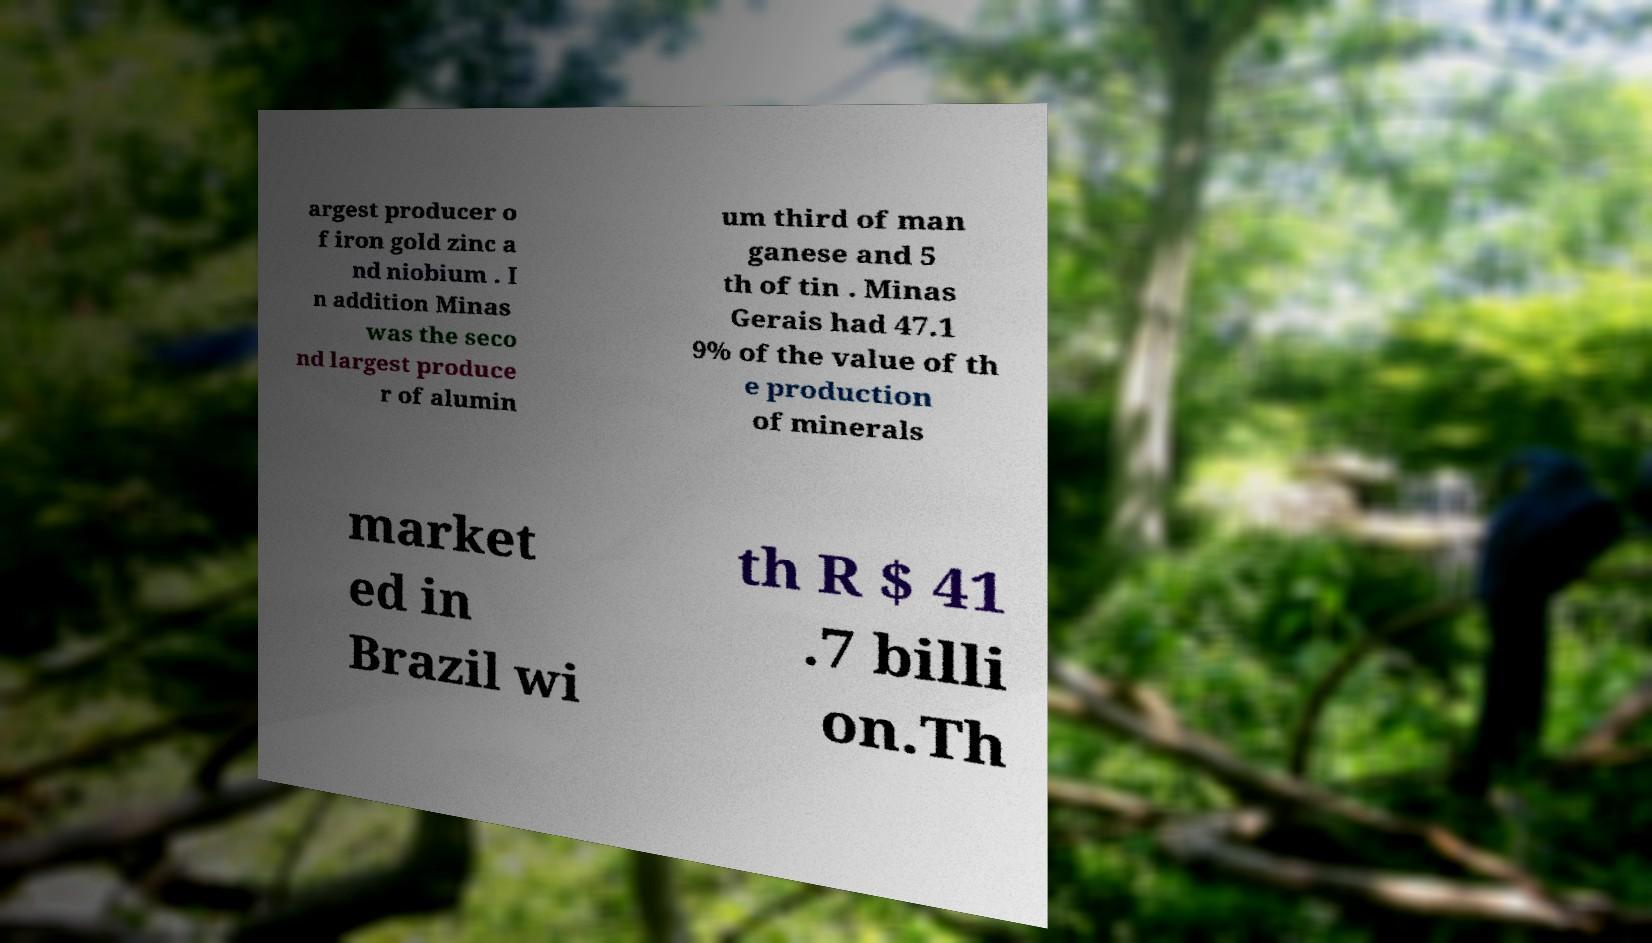Please read and relay the text visible in this image. What does it say? argest producer o f iron gold zinc a nd niobium . I n addition Minas was the seco nd largest produce r of alumin um third of man ganese and 5 th of tin . Minas Gerais had 47.1 9% of the value of th e production of minerals market ed in Brazil wi th R $ 41 .7 billi on.Th 